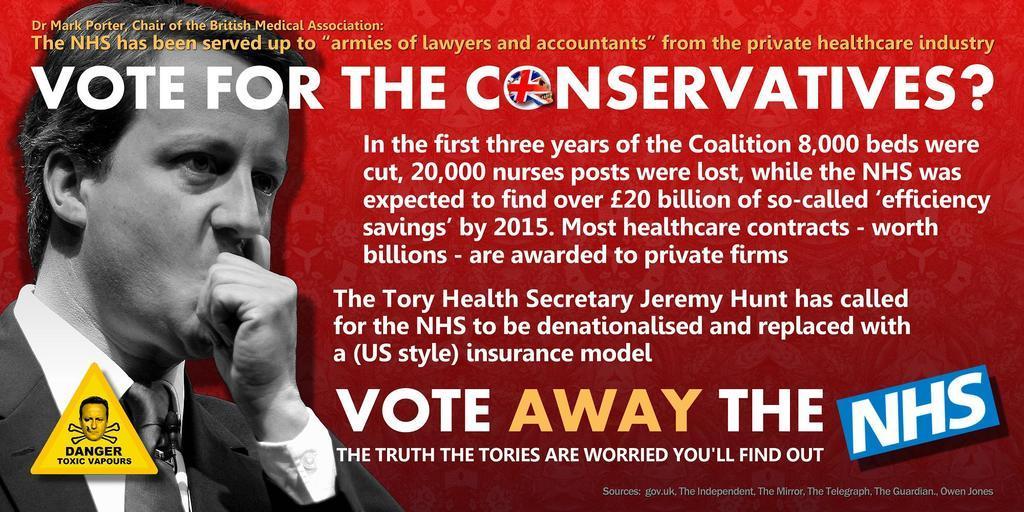In one or two sentences, can you explain what this image depicts? In this image I can see a black and white image of a man. The man is wearing a tie, a shirt and a coat. Here I can see some text on the image. Here I can see a logo on the image. 